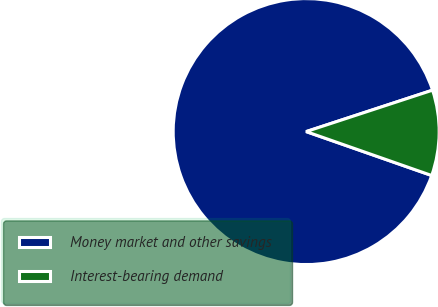Convert chart to OTSL. <chart><loc_0><loc_0><loc_500><loc_500><pie_chart><fcel>Money market and other savings<fcel>Interest-bearing demand<nl><fcel>89.6%<fcel>10.4%<nl></chart> 